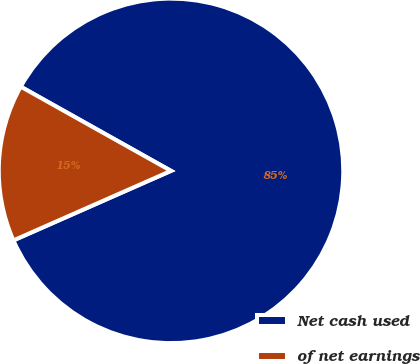Convert chart. <chart><loc_0><loc_0><loc_500><loc_500><pie_chart><fcel>Net cash used<fcel>of net earnings<nl><fcel>85.26%<fcel>14.74%<nl></chart> 